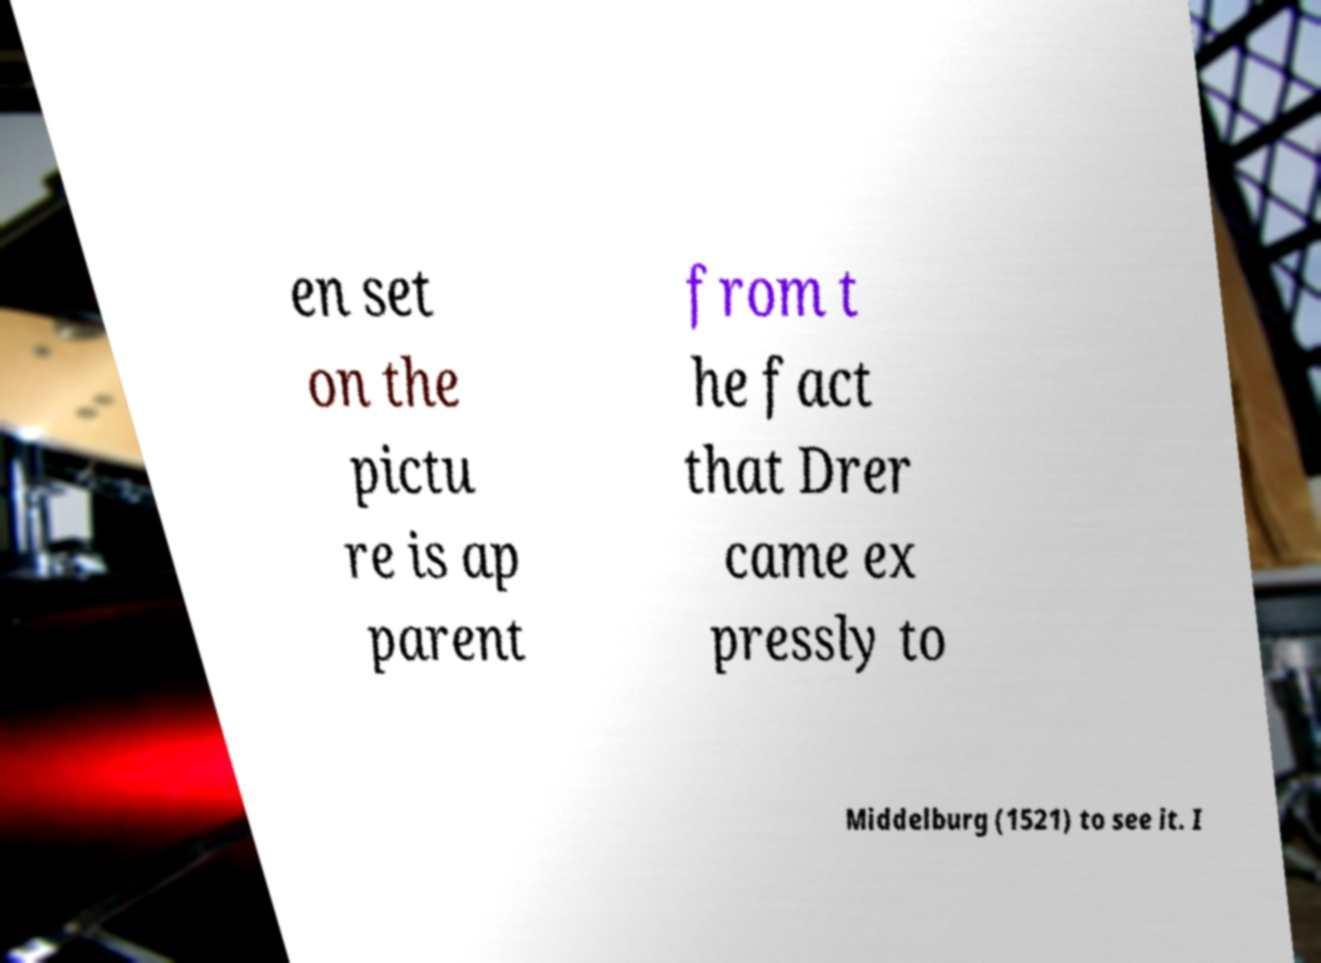There's text embedded in this image that I need extracted. Can you transcribe it verbatim? en set on the pictu re is ap parent from t he fact that Drer came ex pressly to Middelburg (1521) to see it. I 